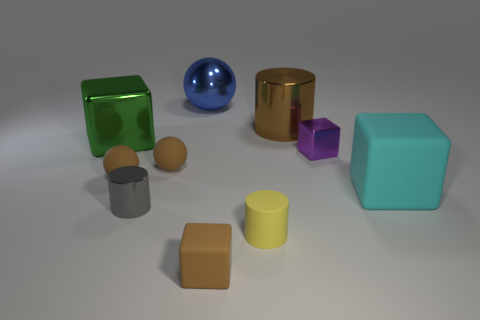There is a small purple object that is on the right side of the big blue sphere; is there a object that is behind it?
Keep it short and to the point. Yes. Does the tiny shiny object to the right of the big blue metal ball have the same shape as the gray object?
Give a very brief answer. No. What shape is the gray object?
Your response must be concise. Cylinder. How many tiny brown things are the same material as the large blue sphere?
Your answer should be compact. 0. Does the big matte cube have the same color as the tiny block that is to the left of the large brown shiny thing?
Offer a terse response. No. What number of yellow rubber objects are there?
Provide a succinct answer. 1. Are there any big metal balls that have the same color as the matte cylinder?
Ensure brevity in your answer.  No. There is a small metal object that is left of the small brown thing in front of the big block in front of the green block; what is its color?
Make the answer very short. Gray. Are the blue thing and the cylinder behind the tiny shiny block made of the same material?
Make the answer very short. Yes. What is the material of the purple block?
Your response must be concise. Metal. 